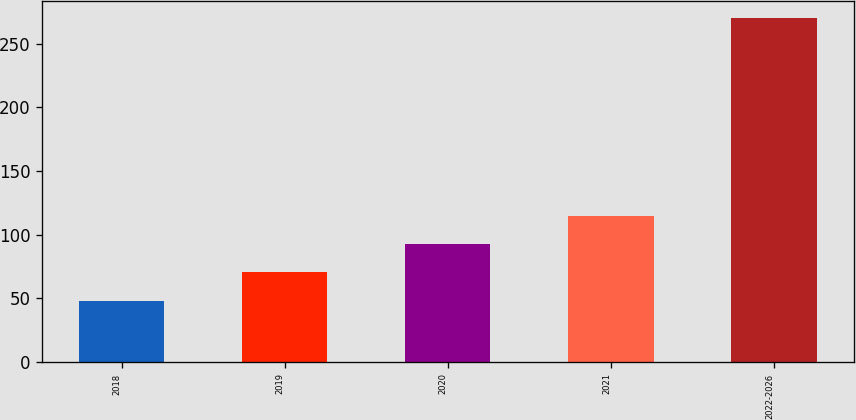Convert chart. <chart><loc_0><loc_0><loc_500><loc_500><bar_chart><fcel>2018<fcel>2019<fcel>2020<fcel>2021<fcel>2022-2026<nl><fcel>48<fcel>70.2<fcel>92.4<fcel>114.6<fcel>270<nl></chart> 